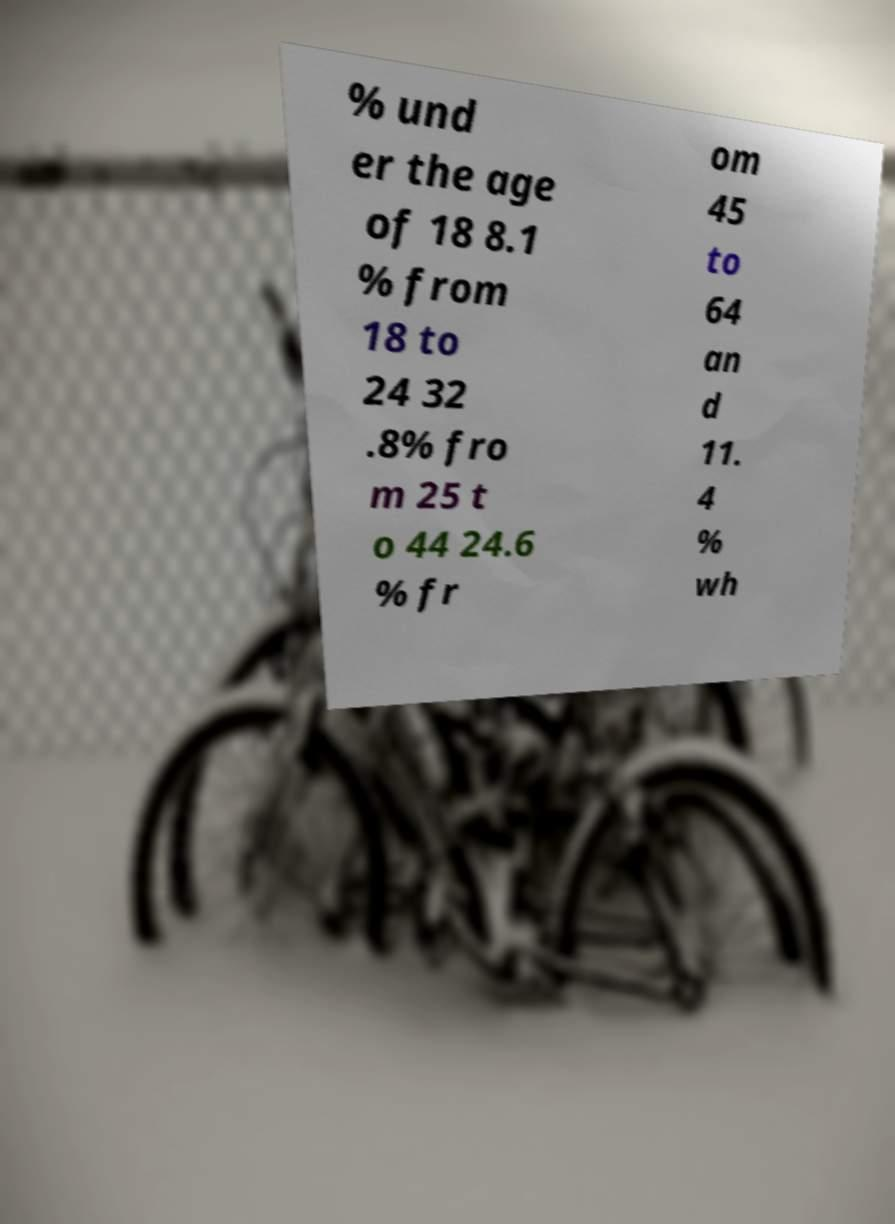For documentation purposes, I need the text within this image transcribed. Could you provide that? % und er the age of 18 8.1 % from 18 to 24 32 .8% fro m 25 t o 44 24.6 % fr om 45 to 64 an d 11. 4 % wh 